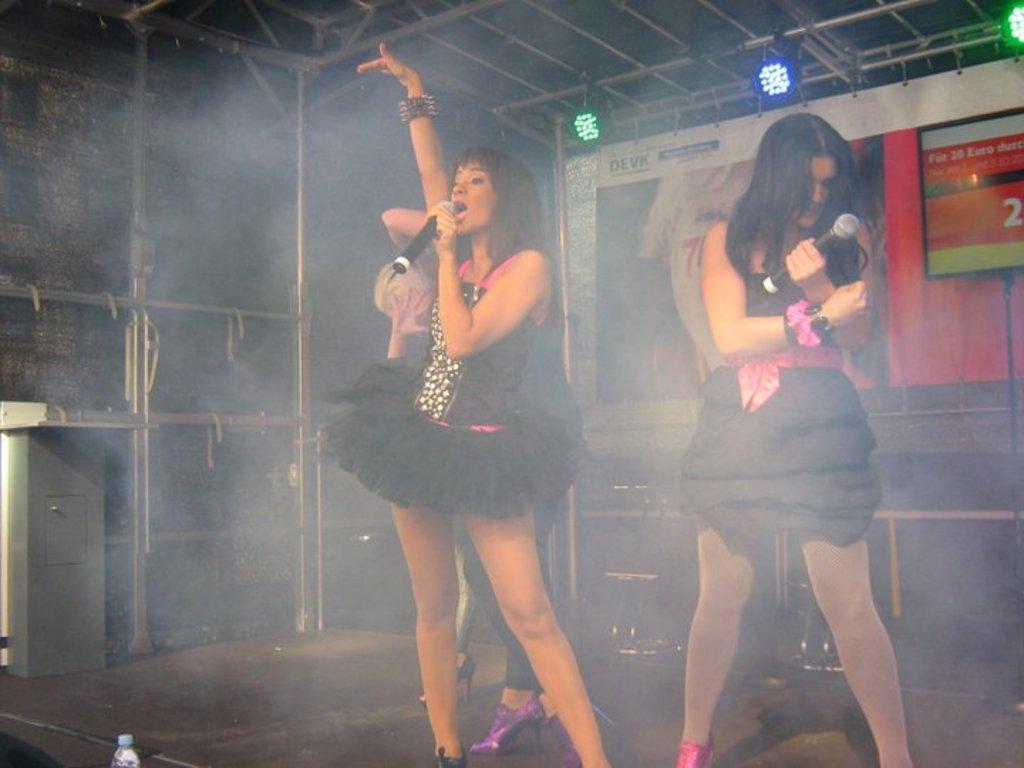In one or two sentences, can you explain what this image depicts? In this image two women wearing a black dress are standing on the floor. They are holding mics in their hand. Behind there is a person standing on the floor. Bottom of image there is a bottle. Behind the persons there is a screen and a poster are attached to the wall. Top of image there are few lights attached to the rods. 